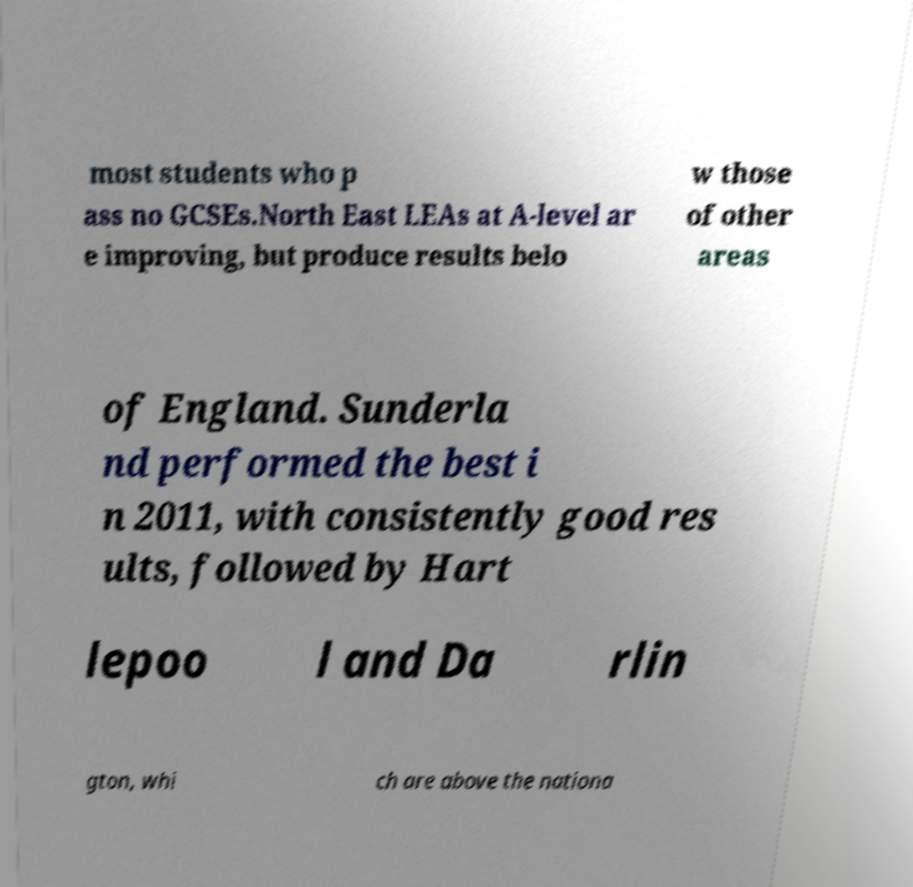There's text embedded in this image that I need extracted. Can you transcribe it verbatim? most students who p ass no GCSEs.North East LEAs at A-level ar e improving, but produce results belo w those of other areas of England. Sunderla nd performed the best i n 2011, with consistently good res ults, followed by Hart lepoo l and Da rlin gton, whi ch are above the nationa 